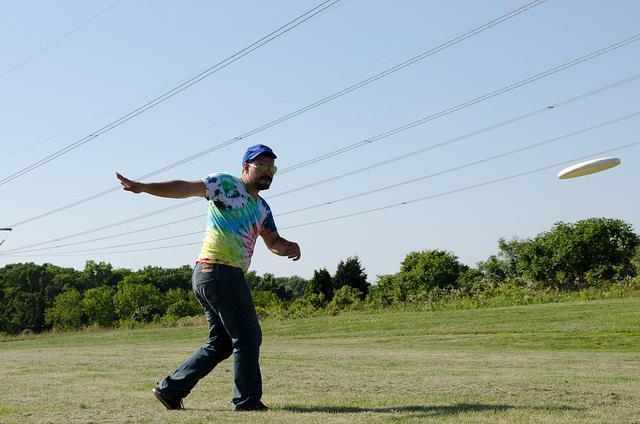How many baby giraffes are in the picture?
Give a very brief answer. 0. 